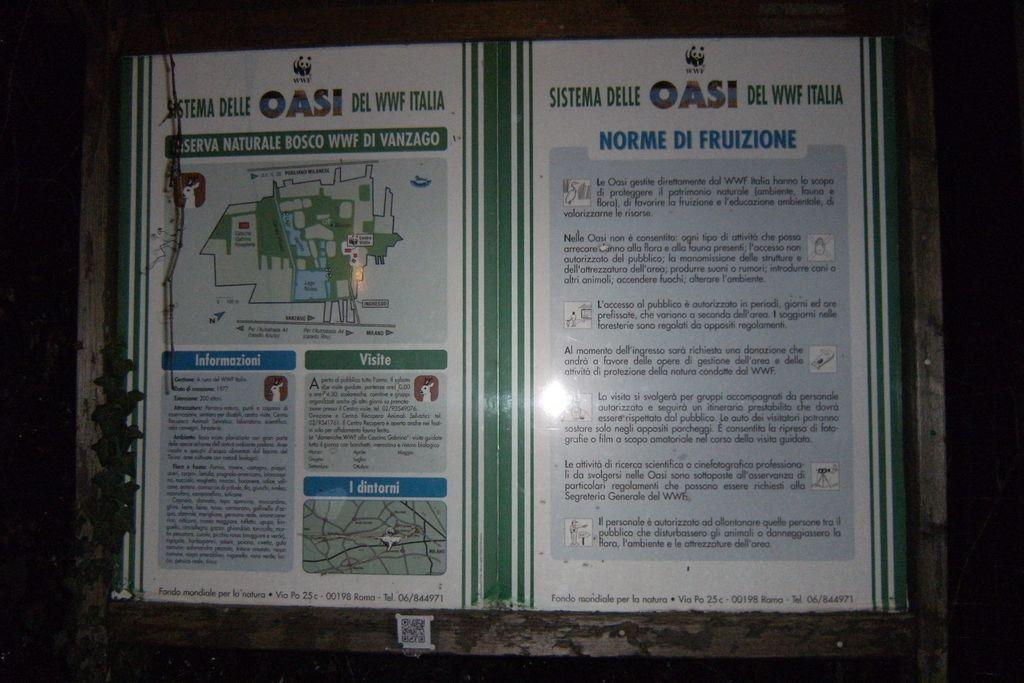<image>
Share a concise interpretation of the image provided. a sign what the word OASI at the top 